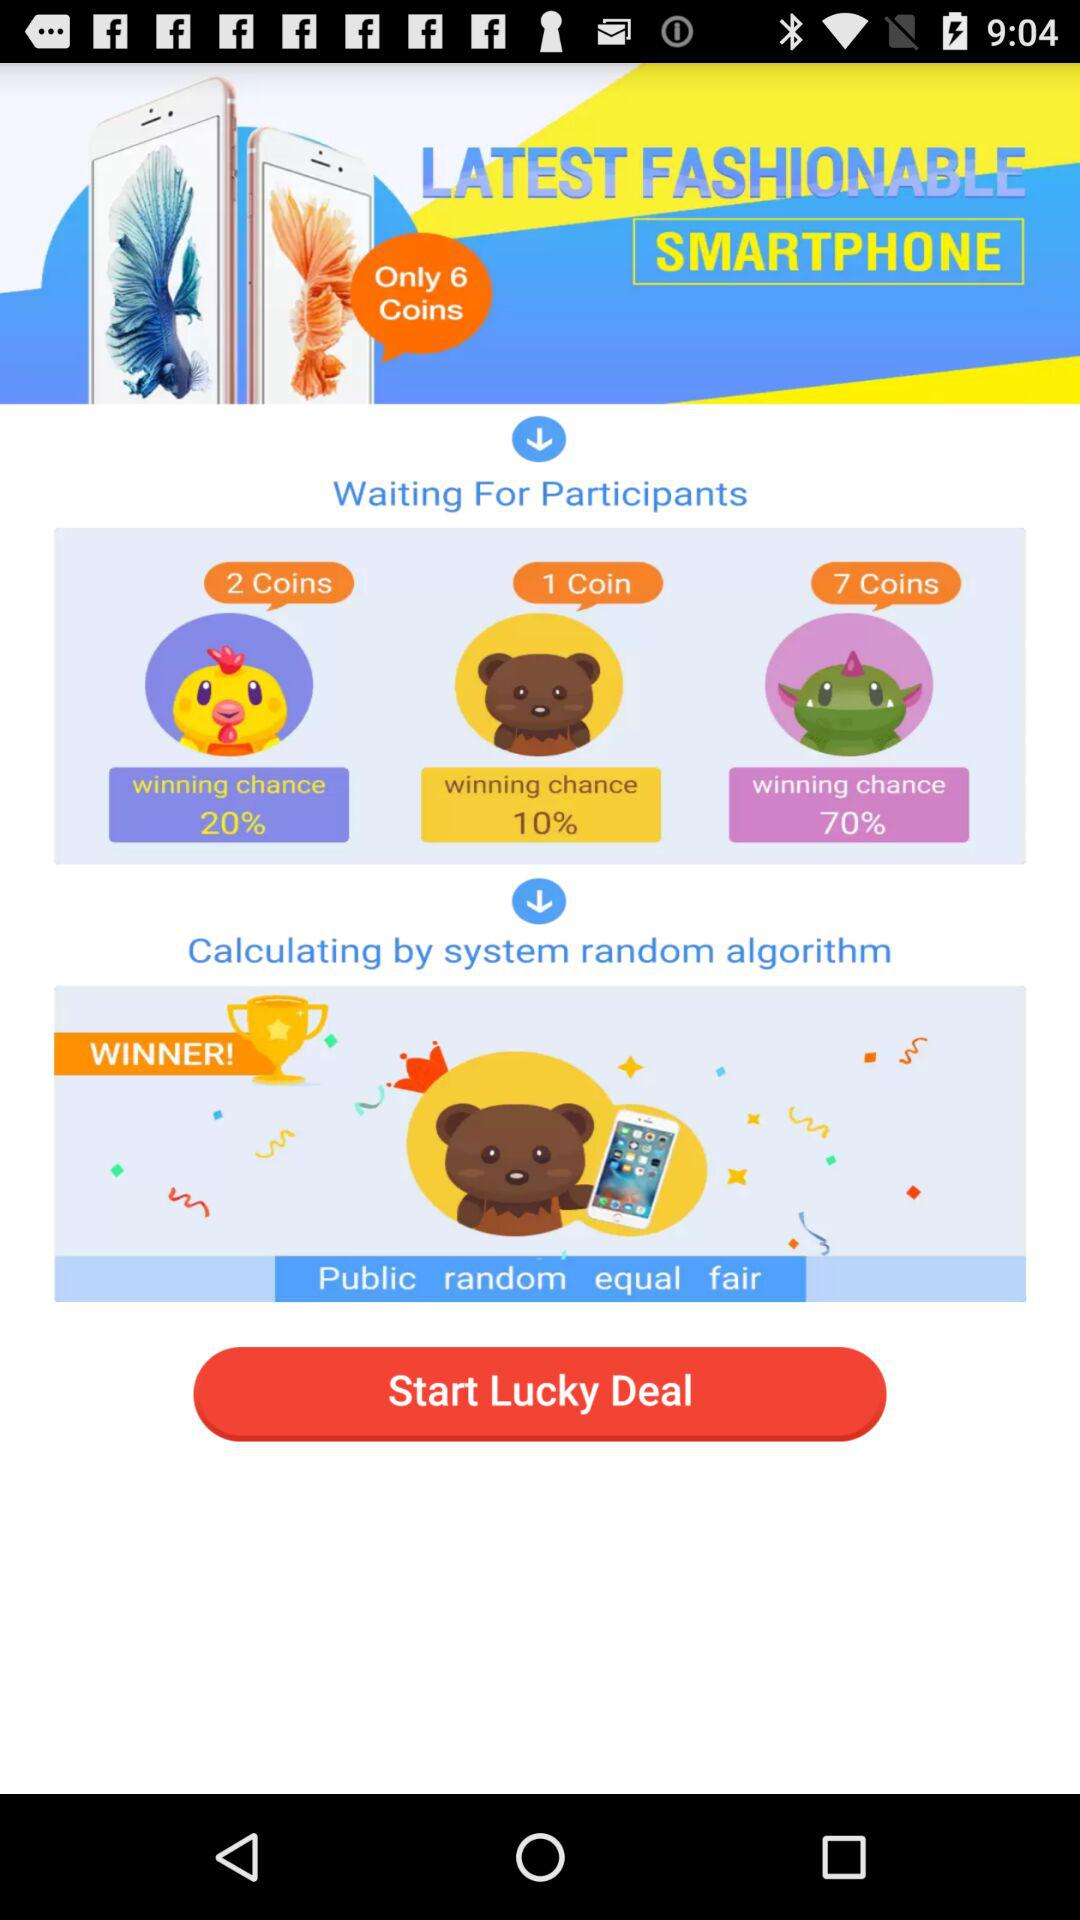How many coins do you win on Chick Emoji? You can win 2 coins on Chick Emoji. 